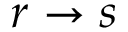Convert formula to latex. <formula><loc_0><loc_0><loc_500><loc_500>r \rightarrow s</formula> 